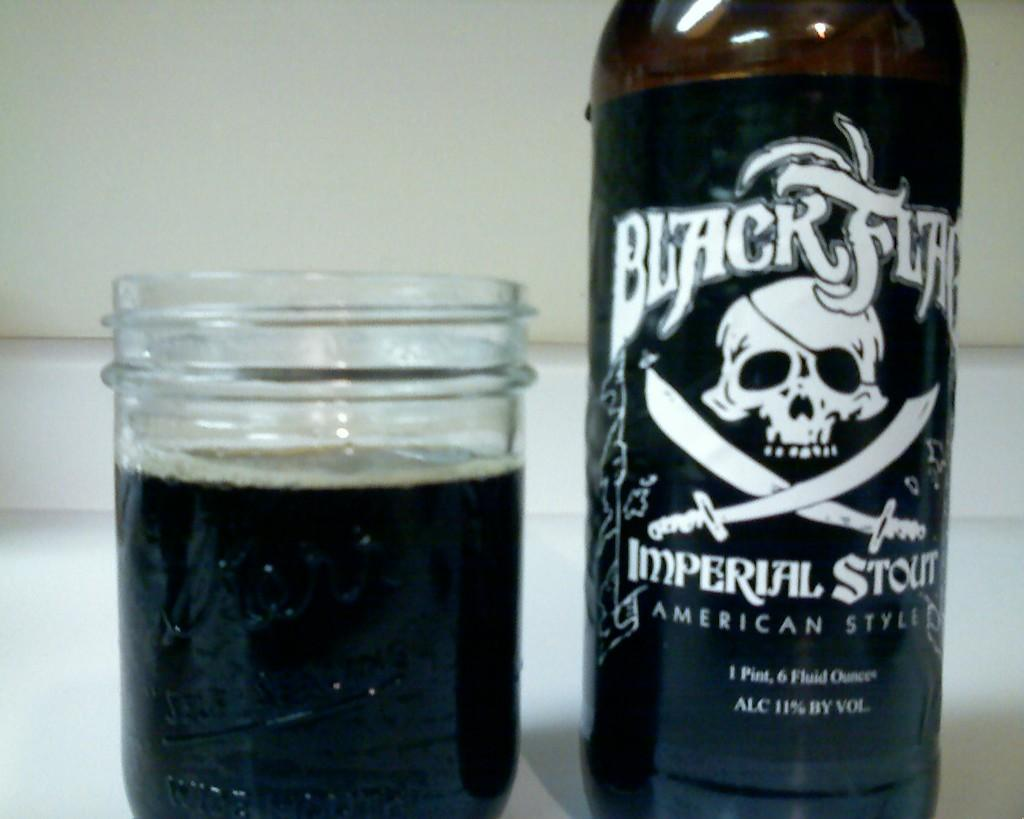<image>
Relay a brief, clear account of the picture shown. A bottle of black flag sits next to a jar filled with the contents 